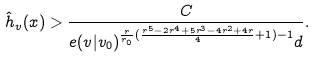Convert formula to latex. <formula><loc_0><loc_0><loc_500><loc_500>\hat { h } _ { v } ( x ) > \frac { C } { e ( v | v _ { 0 } ) ^ { \frac { r } { r _ { 0 } } ( \frac { r ^ { 5 } - 2 r ^ { 4 } + 5 r ^ { 3 } - 4 r ^ { 2 } + 4 r } { 4 } + 1 ) - 1 } d } .</formula> 